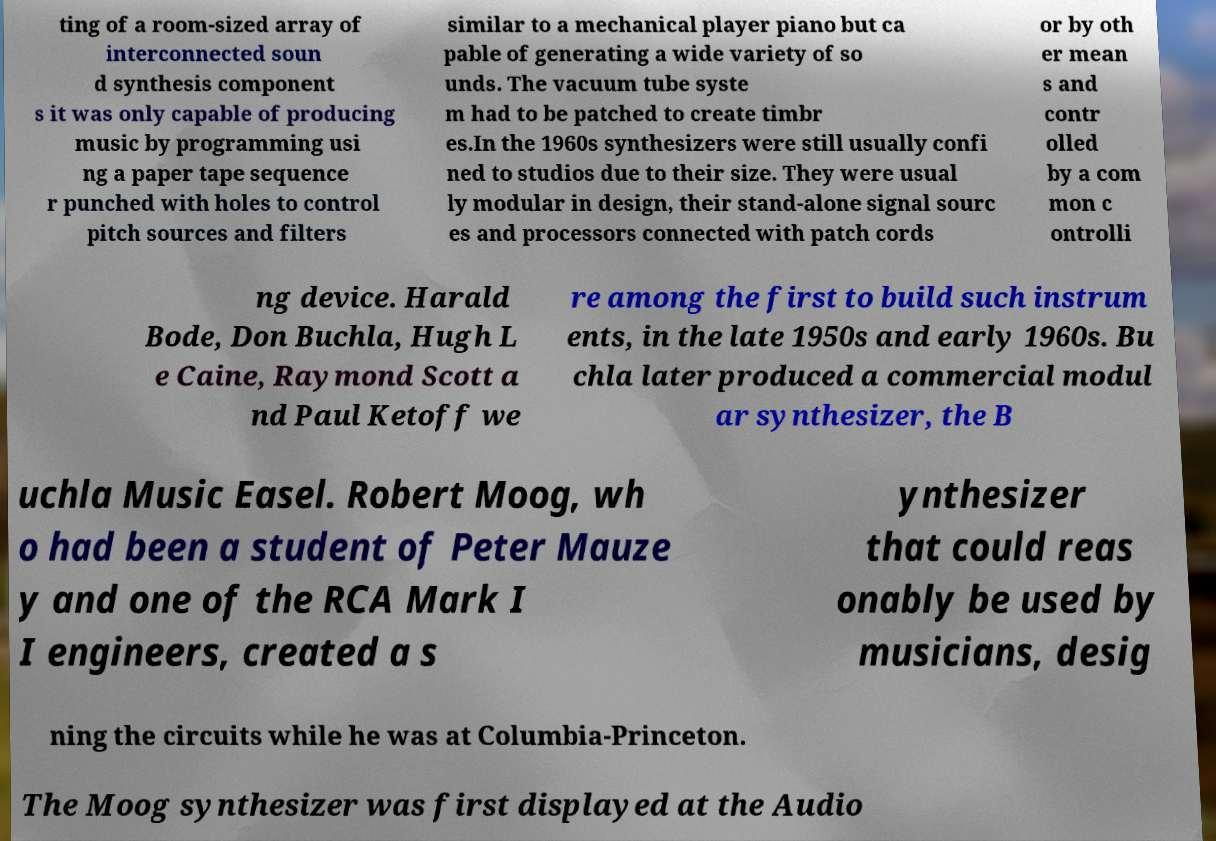For documentation purposes, I need the text within this image transcribed. Could you provide that? ting of a room-sized array of interconnected soun d synthesis component s it was only capable of producing music by programming usi ng a paper tape sequence r punched with holes to control pitch sources and filters similar to a mechanical player piano but ca pable of generating a wide variety of so unds. The vacuum tube syste m had to be patched to create timbr es.In the 1960s synthesizers were still usually confi ned to studios due to their size. They were usual ly modular in design, their stand-alone signal sourc es and processors connected with patch cords or by oth er mean s and contr olled by a com mon c ontrolli ng device. Harald Bode, Don Buchla, Hugh L e Caine, Raymond Scott a nd Paul Ketoff we re among the first to build such instrum ents, in the late 1950s and early 1960s. Bu chla later produced a commercial modul ar synthesizer, the B uchla Music Easel. Robert Moog, wh o had been a student of Peter Mauze y and one of the RCA Mark I I engineers, created a s ynthesizer that could reas onably be used by musicians, desig ning the circuits while he was at Columbia-Princeton. The Moog synthesizer was first displayed at the Audio 